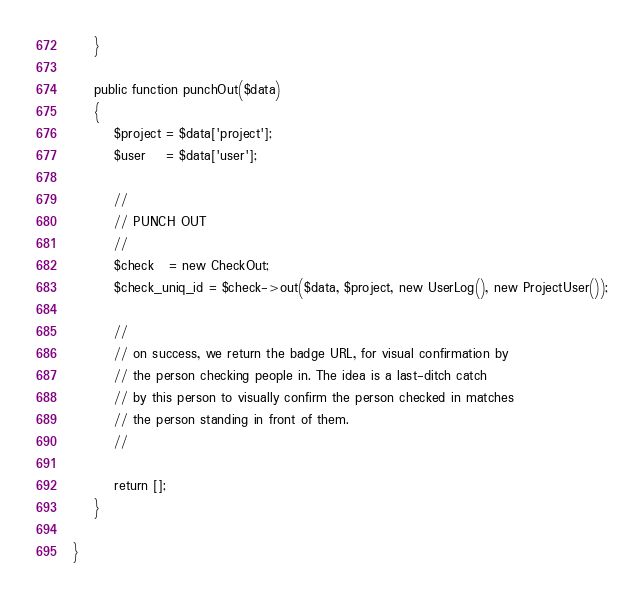<code> <loc_0><loc_0><loc_500><loc_500><_PHP_>    }

    public function punchOut($data)
    {
        $project = $data['project'];
        $user    = $data['user'];

        //
        // PUNCH OUT
        //
        $check   = new CheckOut;
        $check_uniq_id = $check->out($data, $project, new UserLog(), new ProjectUser());

        //
        // on success, we return the badge URL, for visual confirmation by
        // the person checking people in. The idea is a last-ditch catch
        // by this person to visually confirm the person checked in matches
        // the person standing in front of them.
        //

        return [];
    }

}
</code> 